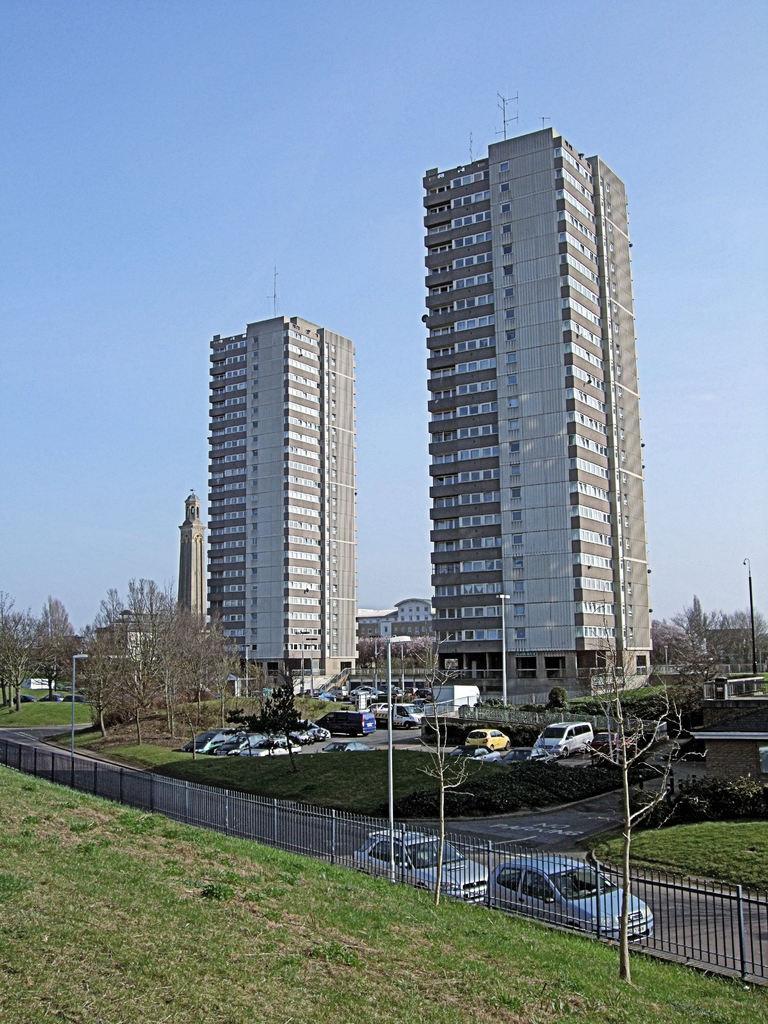Describe this image in one or two sentences. At the foreground of the image we can see fencing, road on which there are some vehicles and at the background of the image there are some trees, vehicles which are parked, there are buildings and clear sky. 